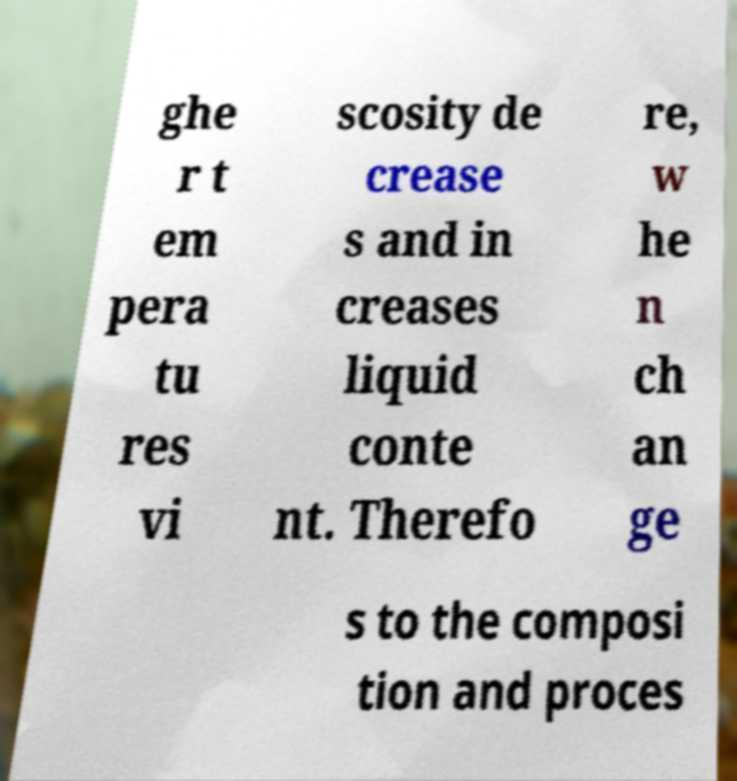What messages or text are displayed in this image? I need them in a readable, typed format. ghe r t em pera tu res vi scosity de crease s and in creases liquid conte nt. Therefo re, w he n ch an ge s to the composi tion and proces 